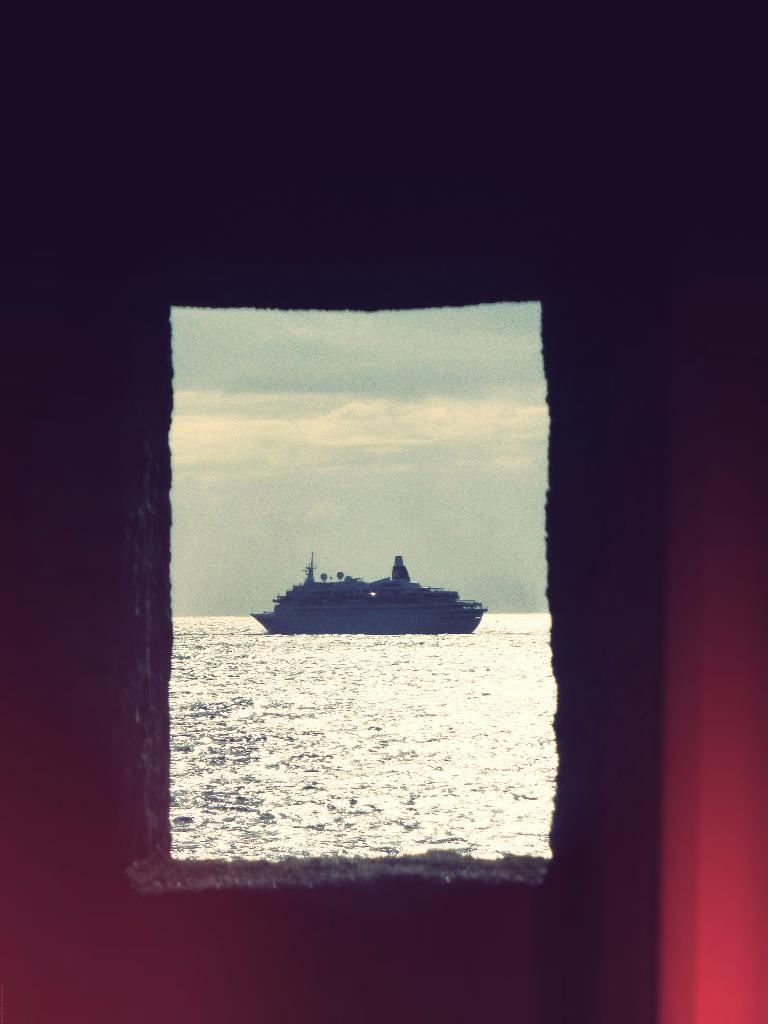What is the main subject of the image? The main subject of the image is a ship in the water. What can be seen in the water? There is water in the image. What is visible in the background of the image? The sky is visible in the background of the image. How would you describe the overall appearance of the image? The background of the image appears to be dark. What type of silk is being used to make the ship's sails in the image? There is no silk or sails present in the image; it features a ship in the water with no visible sails. How does the knife contribute to the image? There is no knife present in the image. 